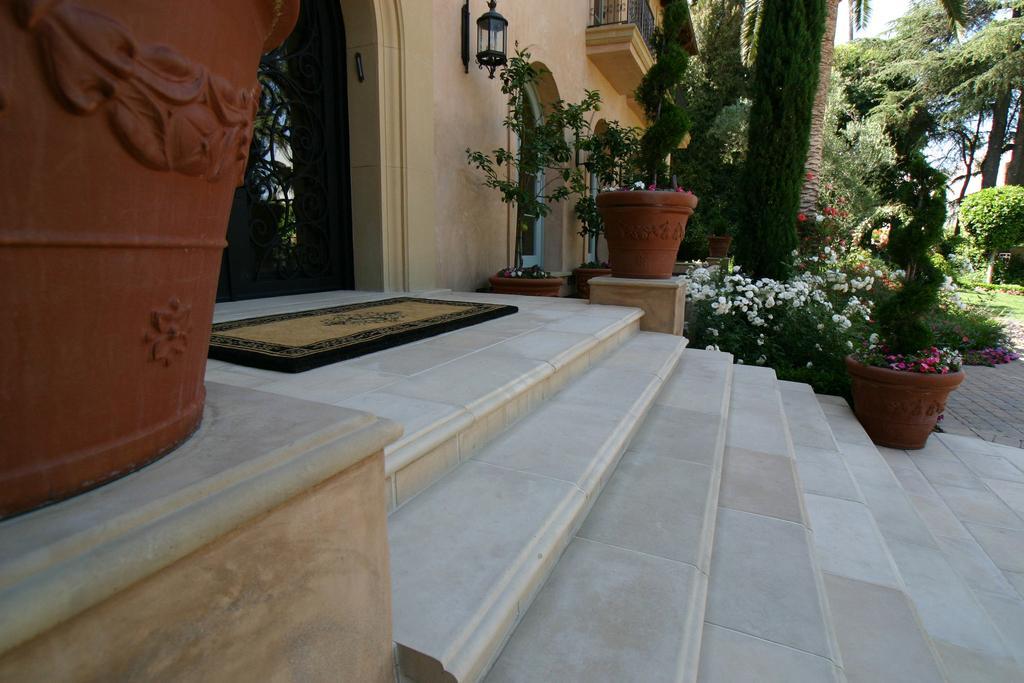Describe this image in one or two sentences. In this picture we can see a doormat, steps, house plants, lamp, wall, railing, windows, flowers and some objects and in the background we can see trees. 